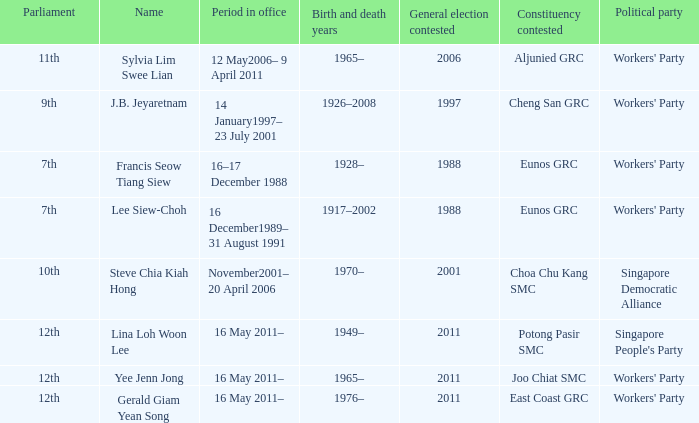What number parliament held it's election in 1997? 9th. 